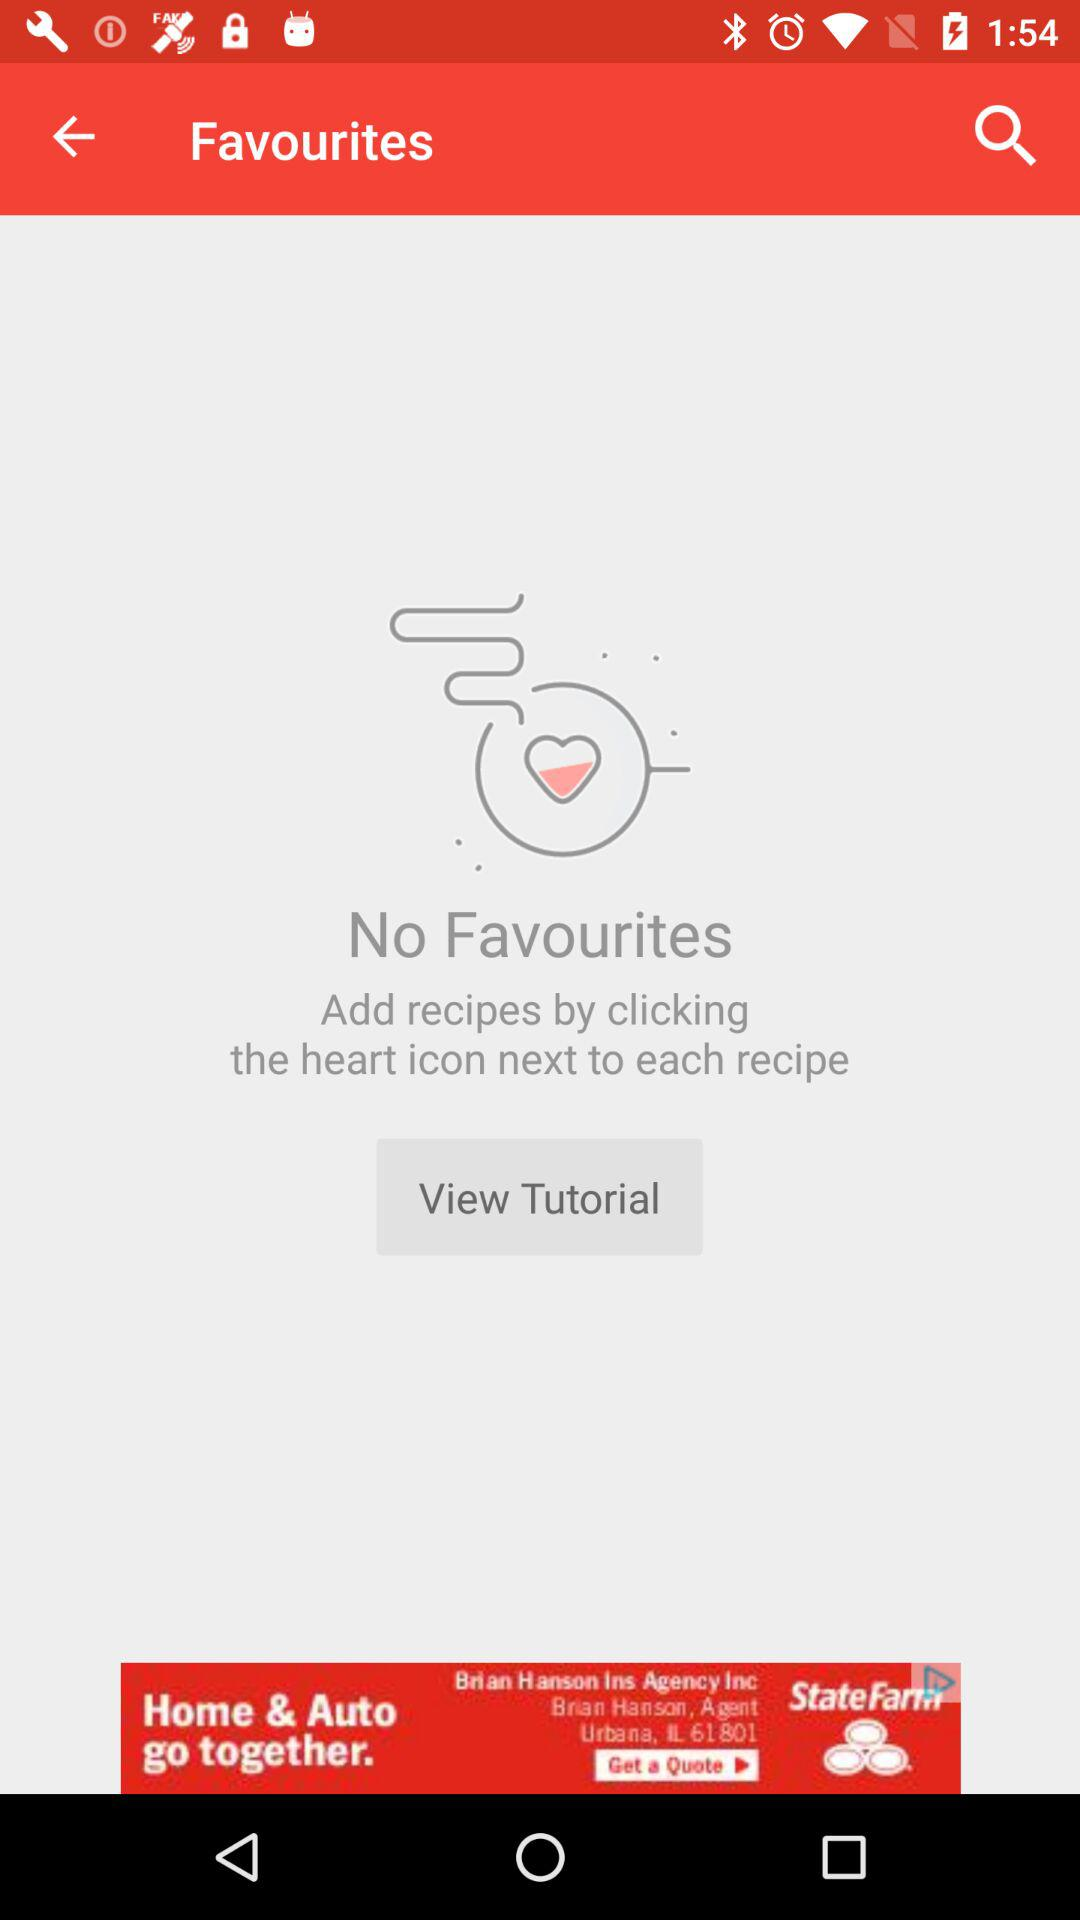What are the names of the recipes?
When the provided information is insufficient, respond with <no answer>. <no answer> 